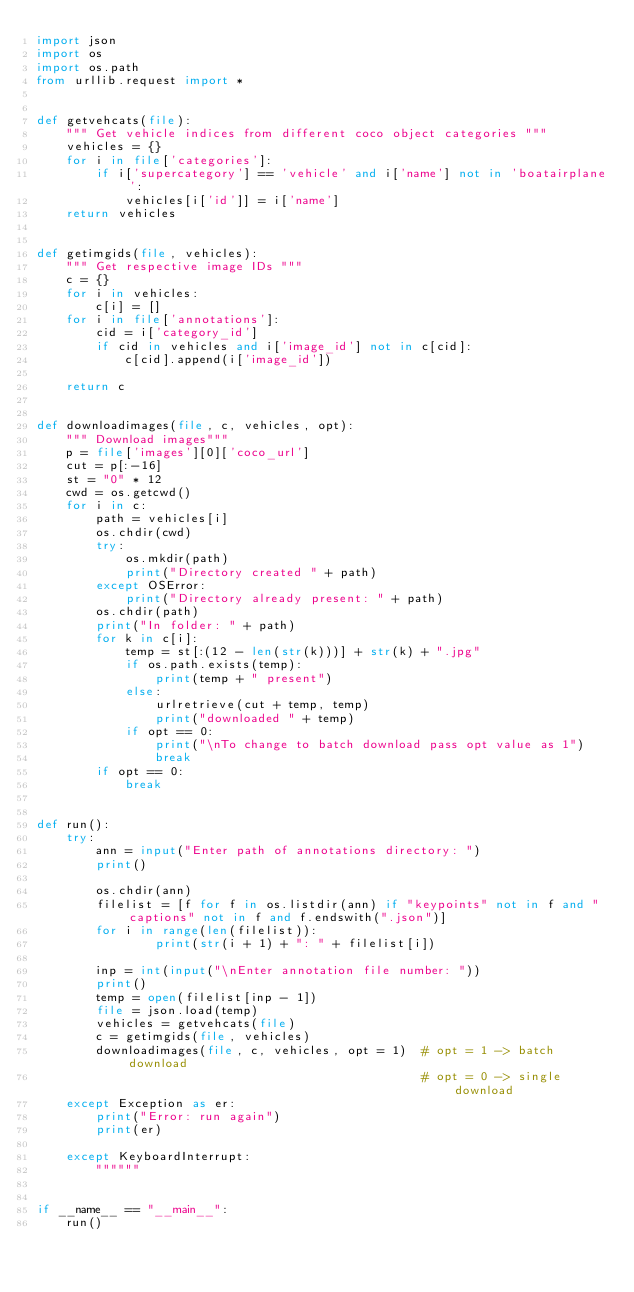Convert code to text. <code><loc_0><loc_0><loc_500><loc_500><_Python_>import json
import os
import os.path
from urllib.request import *


def getvehcats(file):
    """ Get vehicle indices from different coco object categories """
    vehicles = {}
    for i in file['categories']:
        if i['supercategory'] == 'vehicle' and i['name'] not in 'boatairplane':
            vehicles[i['id']] = i['name']
    return vehicles


def getimgids(file, vehicles):
    """ Get respective image IDs """
    c = {}
    for i in vehicles:
        c[i] = []
    for i in file['annotations']:
        cid = i['category_id']
        if cid in vehicles and i['image_id'] not in c[cid]:
            c[cid].append(i['image_id'])

    return c


def downloadimages(file, c, vehicles, opt):
    """ Download images"""
    p = file['images'][0]['coco_url']
    cut = p[:-16]
    st = "0" * 12
    cwd = os.getcwd()
    for i in c:
        path = vehicles[i]
        os.chdir(cwd)
        try:
            os.mkdir(path)
            print("Directory created " + path)            
        except OSError:
            print("Directory already present: " + path)
        os.chdir(path)
        print("In folder: " + path)
        for k in c[i]:
            temp = st[:(12 - len(str(k)))] + str(k) + ".jpg"
            if os.path.exists(temp):                
                print(temp + " present")
            else:
                urlretrieve(cut + temp, temp)
                print("downloaded " + temp)
            if opt == 0:
                print("\nTo change to batch download pass opt value as 1")
                break
        if opt == 0:
            break


def run():
    try:
        ann = input("Enter path of annotations directory: ")
        print()

        os.chdir(ann)
        filelist = [f for f in os.listdir(ann) if "keypoints" not in f and "captions" not in f and f.endswith(".json")]
        for i in range(len(filelist)):    
                print(str(i + 1) + ": " + filelist[i])

        inp = int(input("\nEnter annotation file number: "))
        print()
        temp = open(filelist[inp - 1])
        file = json.load(temp)
        vehicles = getvehcats(file)
        c = getimgids(file, vehicles)
        downloadimages(file, c, vehicles, opt = 1)  # opt = 1 -> batch download
                                                    # opt = 0 -> single download
    except Exception as er:
        print("Error: run again")
        print(er)

    except KeyboardInterrupt:
        """"""


if __name__ == "__main__":
    run()
</code> 